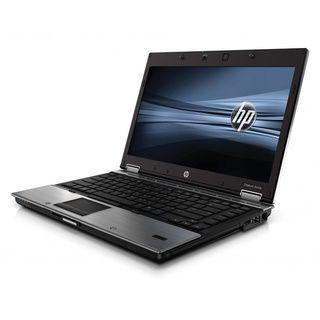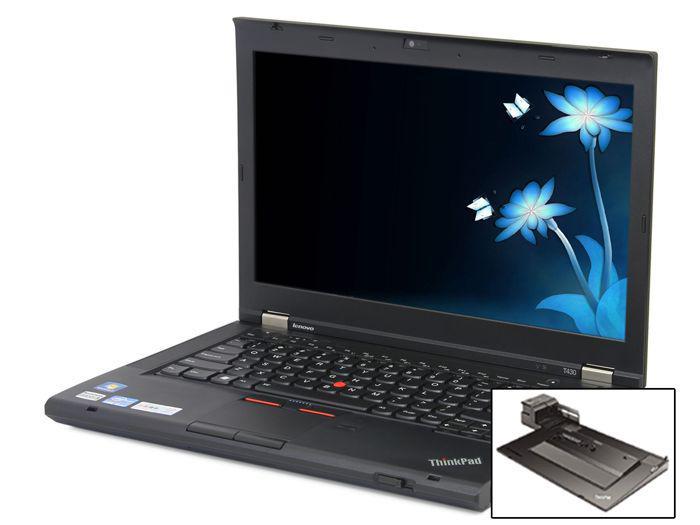The first image is the image on the left, the second image is the image on the right. Analyze the images presented: Is the assertion "An image of a single laptop features a screen saver consisting of horizontal waves of blue tones." valid? Answer yes or no. Yes. The first image is the image on the left, the second image is the image on the right. Given the left and right images, does the statement "the laptop in the image on the right is facing the bottom right" hold true? Answer yes or no. No. 